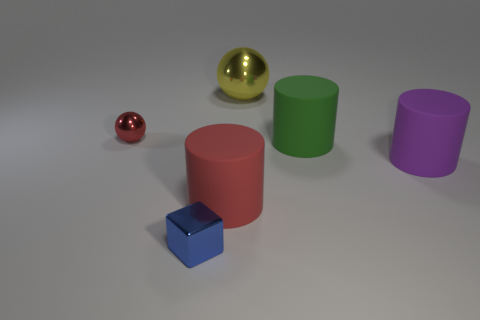What is the color of the large object that is the same material as the tiny red object?
Offer a very short reply. Yellow. What number of tiny blue blocks are made of the same material as the yellow object?
Ensure brevity in your answer.  1. There is a sphere behind the red metallic sphere; is its size the same as the large red matte cylinder?
Make the answer very short. Yes. What color is the shiny ball that is the same size as the green cylinder?
Offer a very short reply. Yellow. There is a red metallic ball; how many large green matte cylinders are in front of it?
Your response must be concise. 1. Are there any rubber things?
Make the answer very short. Yes. There is a sphere that is to the left of the thing that is behind the metallic sphere that is on the left side of the big red thing; how big is it?
Ensure brevity in your answer.  Small. How many other things are there of the same size as the yellow object?
Offer a terse response. 3. There is a ball that is on the left side of the large metallic thing; what size is it?
Give a very brief answer. Small. Is there anything else that has the same color as the large ball?
Your response must be concise. No. 